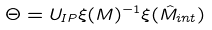<formula> <loc_0><loc_0><loc_500><loc_500>\Theta = U _ { I P } \xi ( M ) ^ { - 1 } \xi ( { \hat { M } } _ { i n t } )</formula> 